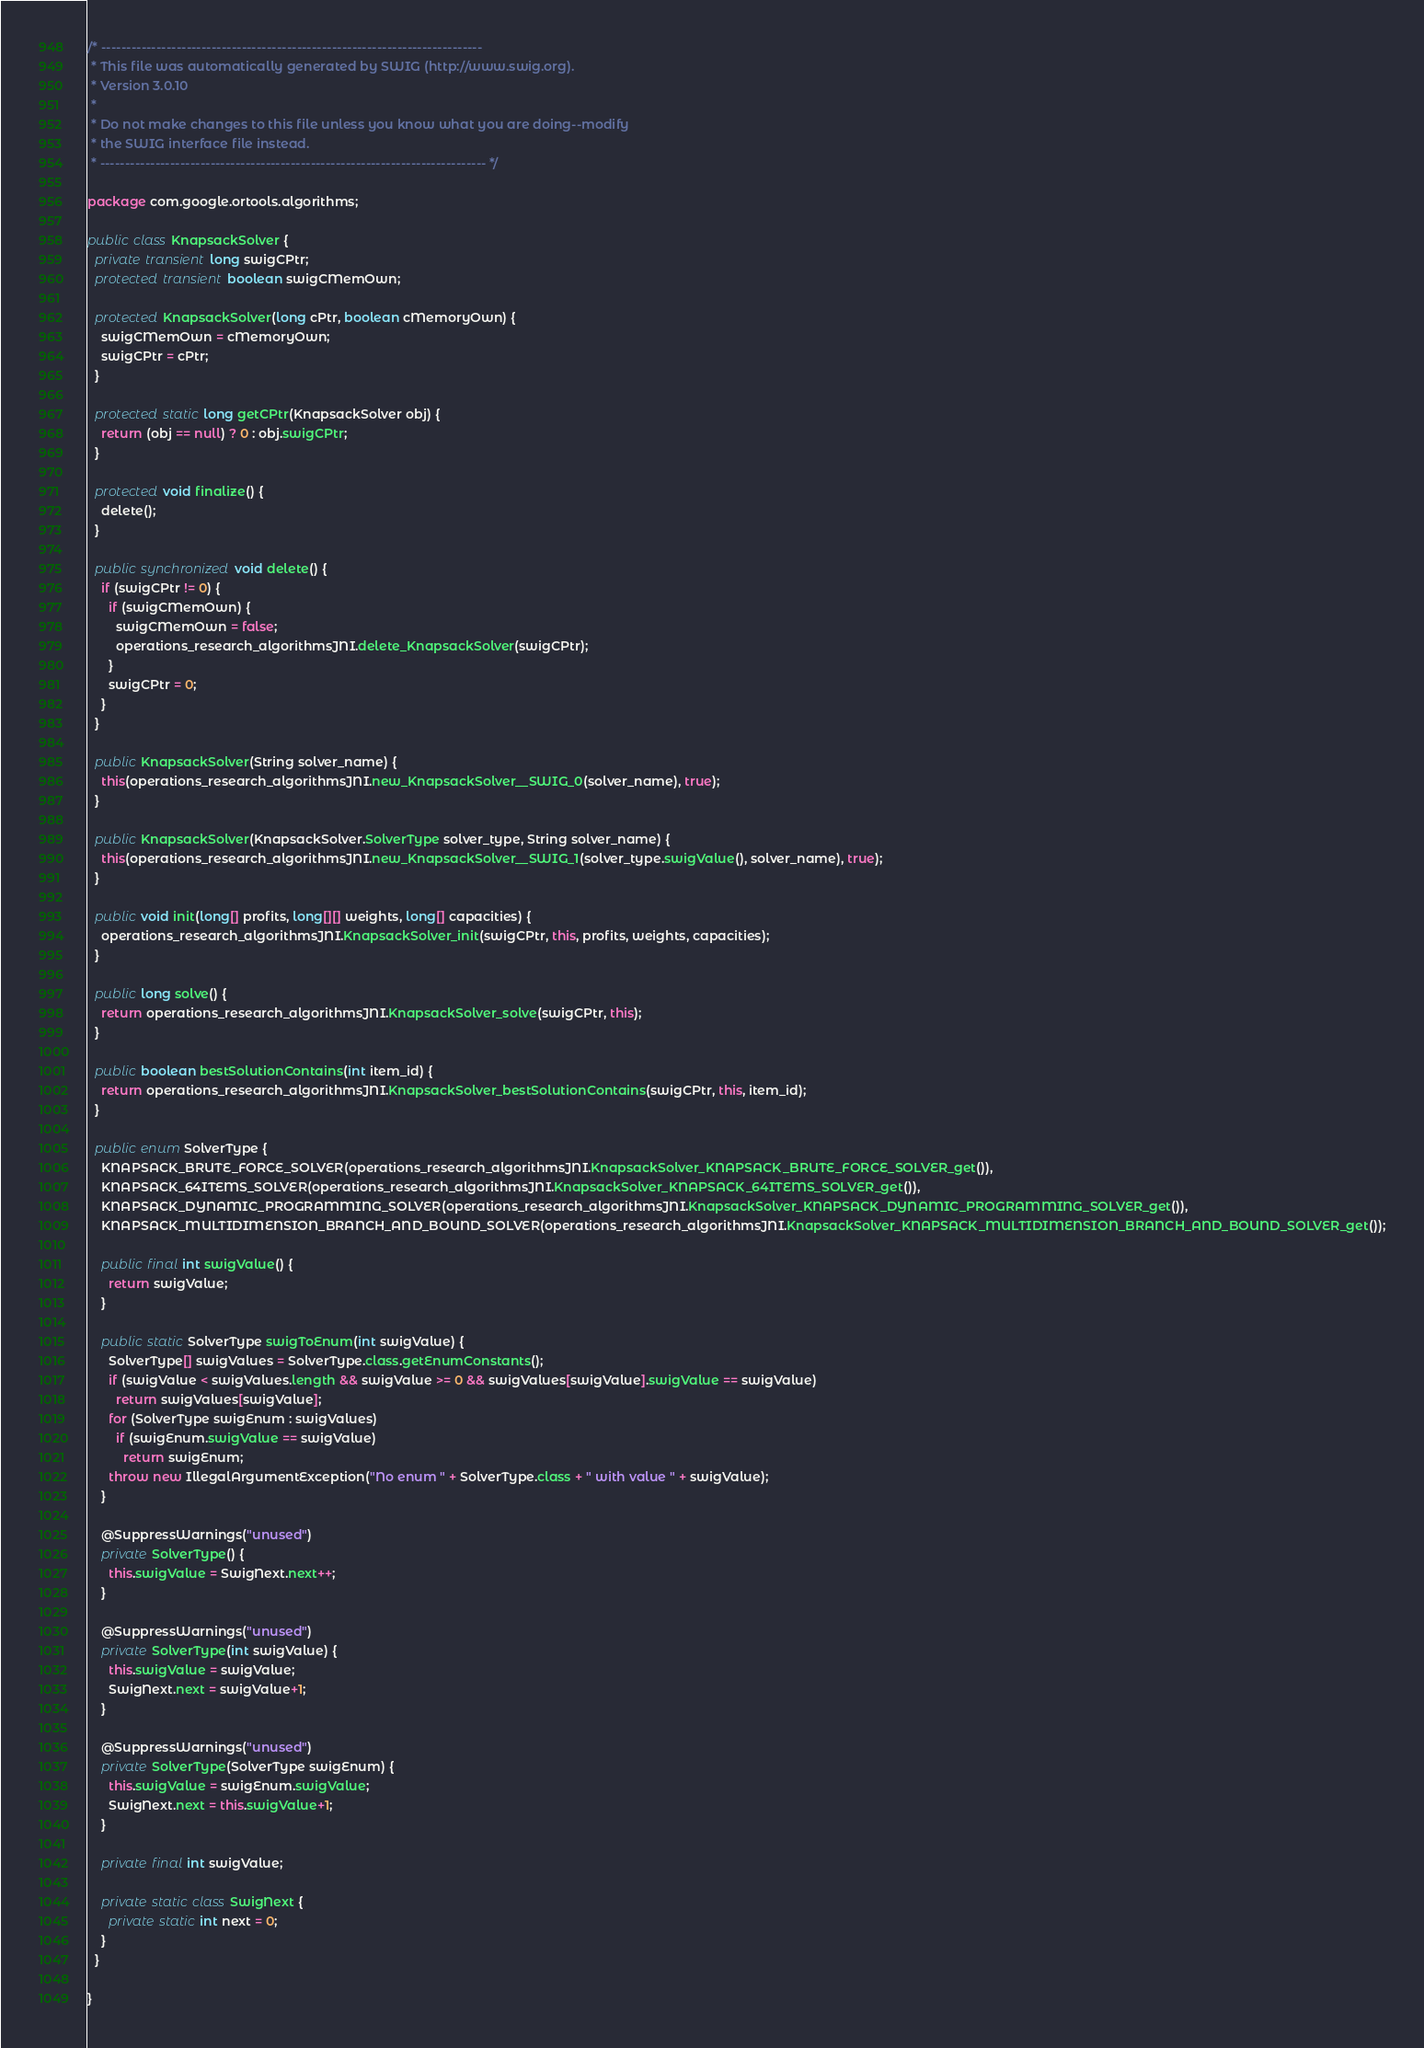<code> <loc_0><loc_0><loc_500><loc_500><_Java_>/* ----------------------------------------------------------------------------
 * This file was automatically generated by SWIG (http://www.swig.org).
 * Version 3.0.10
 *
 * Do not make changes to this file unless you know what you are doing--modify
 * the SWIG interface file instead.
 * ----------------------------------------------------------------------------- */

package com.google.ortools.algorithms;

public class KnapsackSolver {
  private transient long swigCPtr;
  protected transient boolean swigCMemOwn;

  protected KnapsackSolver(long cPtr, boolean cMemoryOwn) {
    swigCMemOwn = cMemoryOwn;
    swigCPtr = cPtr;
  }

  protected static long getCPtr(KnapsackSolver obj) {
    return (obj == null) ? 0 : obj.swigCPtr;
  }

  protected void finalize() {
    delete();
  }

  public synchronized void delete() {
    if (swigCPtr != 0) {
      if (swigCMemOwn) {
        swigCMemOwn = false;
        operations_research_algorithmsJNI.delete_KnapsackSolver(swigCPtr);
      }
      swigCPtr = 0;
    }
  }

  public KnapsackSolver(String solver_name) {
    this(operations_research_algorithmsJNI.new_KnapsackSolver__SWIG_0(solver_name), true);
  }

  public KnapsackSolver(KnapsackSolver.SolverType solver_type, String solver_name) {
    this(operations_research_algorithmsJNI.new_KnapsackSolver__SWIG_1(solver_type.swigValue(), solver_name), true);
  }

  public void init(long[] profits, long[][] weights, long[] capacities) {
    operations_research_algorithmsJNI.KnapsackSolver_init(swigCPtr, this, profits, weights, capacities);
  }

  public long solve() {
    return operations_research_algorithmsJNI.KnapsackSolver_solve(swigCPtr, this);
  }

  public boolean bestSolutionContains(int item_id) {
    return operations_research_algorithmsJNI.KnapsackSolver_bestSolutionContains(swigCPtr, this, item_id);
  }

  public enum SolverType {
    KNAPSACK_BRUTE_FORCE_SOLVER(operations_research_algorithmsJNI.KnapsackSolver_KNAPSACK_BRUTE_FORCE_SOLVER_get()),
    KNAPSACK_64ITEMS_SOLVER(operations_research_algorithmsJNI.KnapsackSolver_KNAPSACK_64ITEMS_SOLVER_get()),
    KNAPSACK_DYNAMIC_PROGRAMMING_SOLVER(operations_research_algorithmsJNI.KnapsackSolver_KNAPSACK_DYNAMIC_PROGRAMMING_SOLVER_get()),
    KNAPSACK_MULTIDIMENSION_BRANCH_AND_BOUND_SOLVER(operations_research_algorithmsJNI.KnapsackSolver_KNAPSACK_MULTIDIMENSION_BRANCH_AND_BOUND_SOLVER_get());

    public final int swigValue() {
      return swigValue;
    }

    public static SolverType swigToEnum(int swigValue) {
      SolverType[] swigValues = SolverType.class.getEnumConstants();
      if (swigValue < swigValues.length && swigValue >= 0 && swigValues[swigValue].swigValue == swigValue)
        return swigValues[swigValue];
      for (SolverType swigEnum : swigValues)
        if (swigEnum.swigValue == swigValue)
          return swigEnum;
      throw new IllegalArgumentException("No enum " + SolverType.class + " with value " + swigValue);
    }

    @SuppressWarnings("unused")
    private SolverType() {
      this.swigValue = SwigNext.next++;
    }

    @SuppressWarnings("unused")
    private SolverType(int swigValue) {
      this.swigValue = swigValue;
      SwigNext.next = swigValue+1;
    }

    @SuppressWarnings("unused")
    private SolverType(SolverType swigEnum) {
      this.swigValue = swigEnum.swigValue;
      SwigNext.next = this.swigValue+1;
    }

    private final int swigValue;

    private static class SwigNext {
      private static int next = 0;
    }
  }

}
</code> 